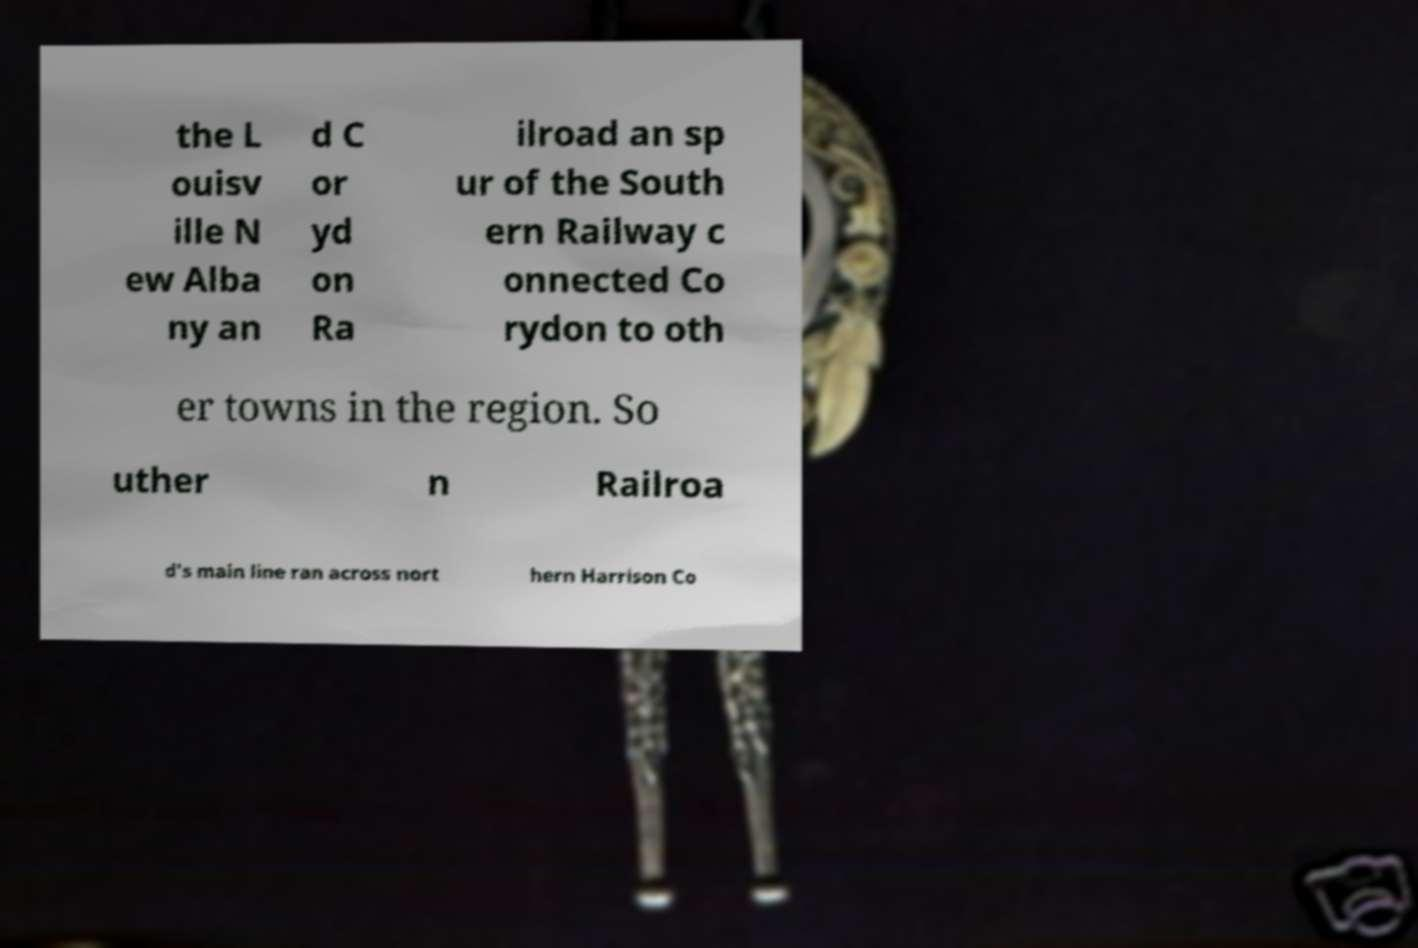What messages or text are displayed in this image? I need them in a readable, typed format. the L ouisv ille N ew Alba ny an d C or yd on Ra ilroad an sp ur of the South ern Railway c onnected Co rydon to oth er towns in the region. So uther n Railroa d's main line ran across nort hern Harrison Co 